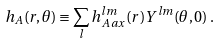Convert formula to latex. <formula><loc_0><loc_0><loc_500><loc_500>h _ { A } ( r , \theta ) \equiv \sum _ { l } h _ { A \, a x } ^ { l m } ( r ) Y ^ { l m } ( \theta , 0 ) \, .</formula> 